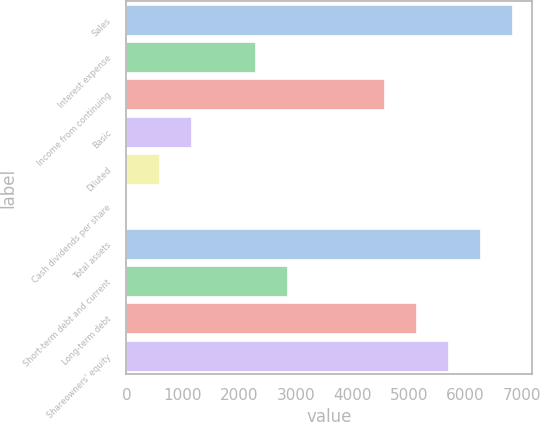Convert chart. <chart><loc_0><loc_0><loc_500><loc_500><bar_chart><fcel>Sales<fcel>Interest expense<fcel>Income from continuing<fcel>Basic<fcel>Diluted<fcel>Cash dividends per share<fcel>Total assets<fcel>Short-term debt and current<fcel>Long-term debt<fcel>Shareowners' equity<nl><fcel>6837.08<fcel>2279.8<fcel>4558.44<fcel>1140.48<fcel>570.82<fcel>1.16<fcel>6267.42<fcel>2849.46<fcel>5128.1<fcel>5697.76<nl></chart> 